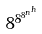<formula> <loc_0><loc_0><loc_500><loc_500>8 ^ { 8 ^ { 8 ^ { n ^ { h } } } }</formula> 